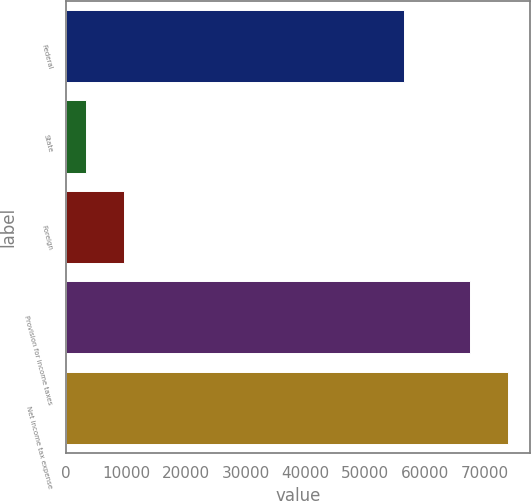<chart> <loc_0><loc_0><loc_500><loc_500><bar_chart><fcel>Federal<fcel>State<fcel>Foreign<fcel>Provision for income taxes<fcel>Net income tax expense<nl><fcel>56489<fcel>3308<fcel>9729.4<fcel>67522<fcel>73943.4<nl></chart> 